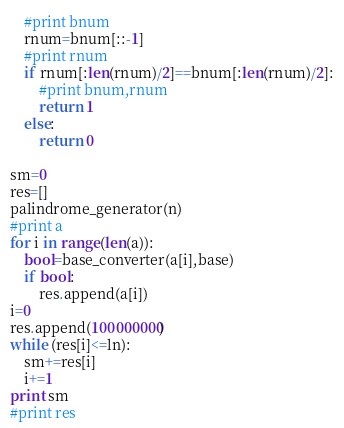Convert code to text. <code><loc_0><loc_0><loc_500><loc_500><_Python_>	#print bnum		
	rnum=bnum[::-1]
	#print rnum
	if rnum[:len(rnum)/2]==bnum[:len(rnum)/2]:
		#print bnum,rnum
		return 1
	else:
		return 0
		
sm=0	
res=[]
palindrome_generator(n)
#print a
for i in range(len(a)):
	bool=base_converter(a[i],base)
	if bool:
		res.append(a[i])
i=0
res.append(100000000)
while (res[i]<=ln):
	sm+=res[i]
	i+=1
print sm
#print res
</code> 